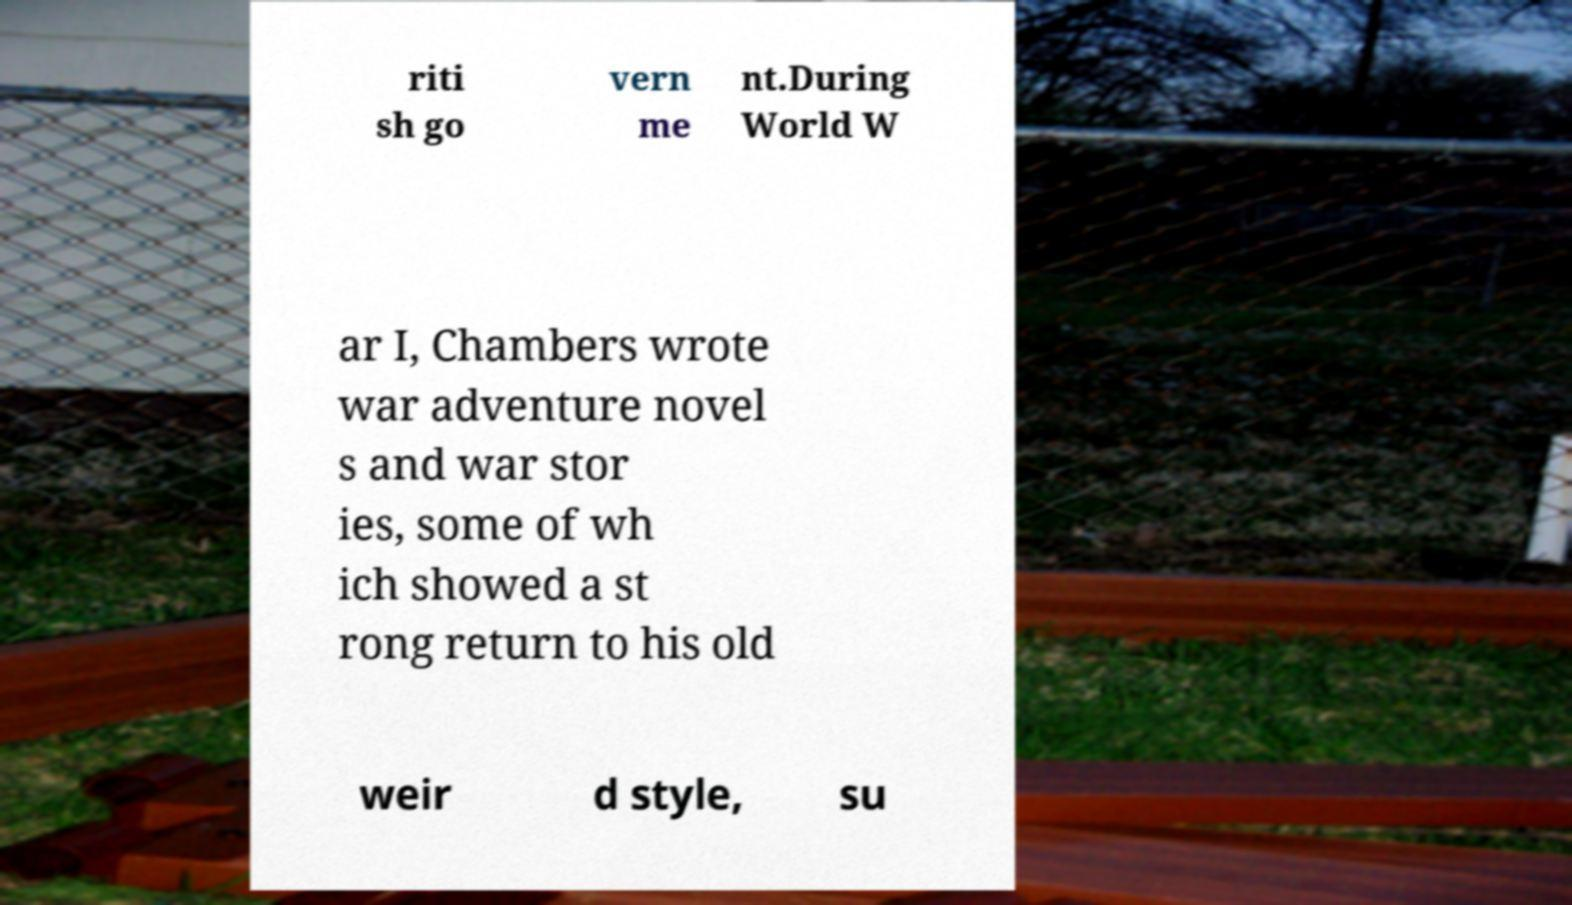Can you accurately transcribe the text from the provided image for me? riti sh go vern me nt.During World W ar I, Chambers wrote war adventure novel s and war stor ies, some of wh ich showed a st rong return to his old weir d style, su 